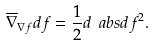Convert formula to latex. <formula><loc_0><loc_0><loc_500><loc_500>\overline { \nabla } _ { \nabla f } d f = \frac { 1 } { 2 } d \ a b s { d f } ^ { 2 } .</formula> 